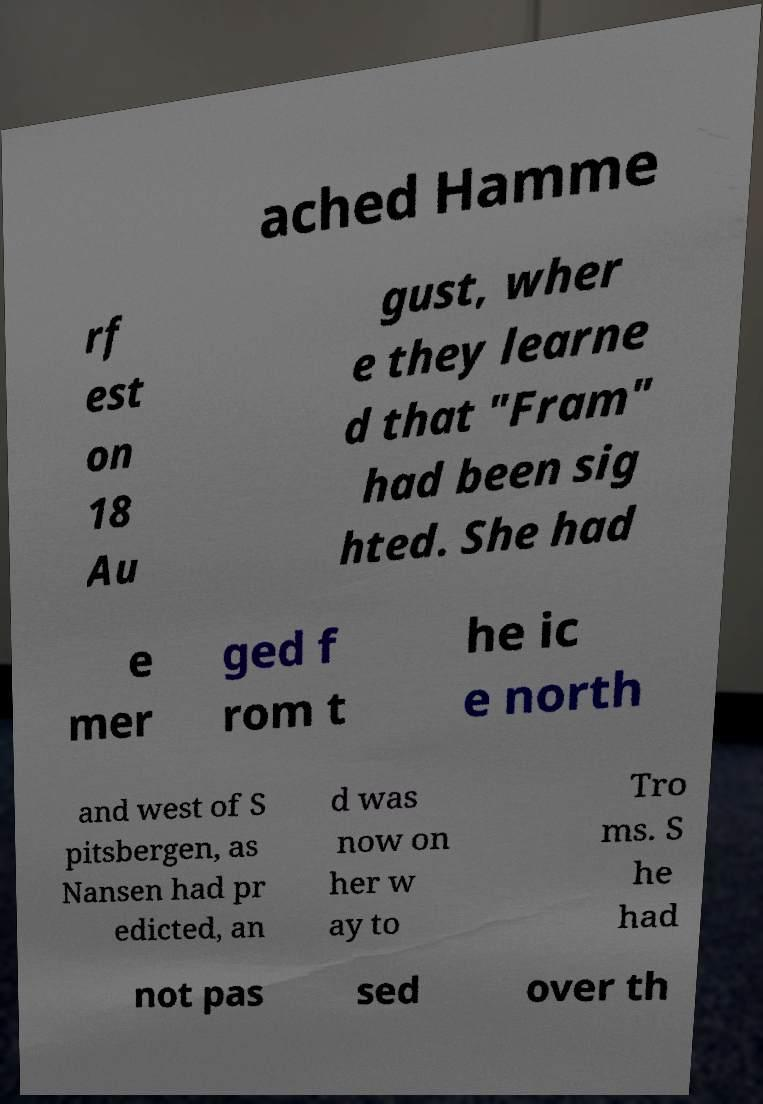Can you accurately transcribe the text from the provided image for me? ached Hamme rf est on 18 Au gust, wher e they learne d that "Fram" had been sig hted. She had e mer ged f rom t he ic e north and west of S pitsbergen, as Nansen had pr edicted, an d was now on her w ay to Tro ms. S he had not pas sed over th 